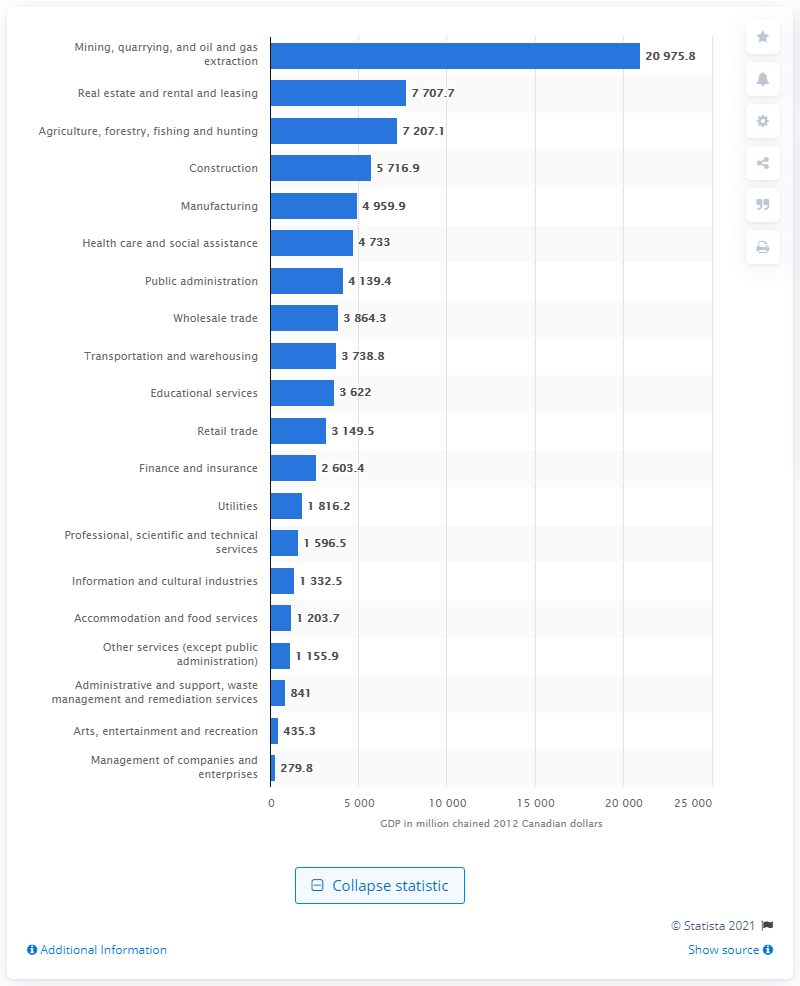Mention a couple of crucial points in this snapshot. In 2012, the Gross Domestic Product (GDP) of Saskatchewan's construction industry was 5,716.9 million Canadian dollars. 